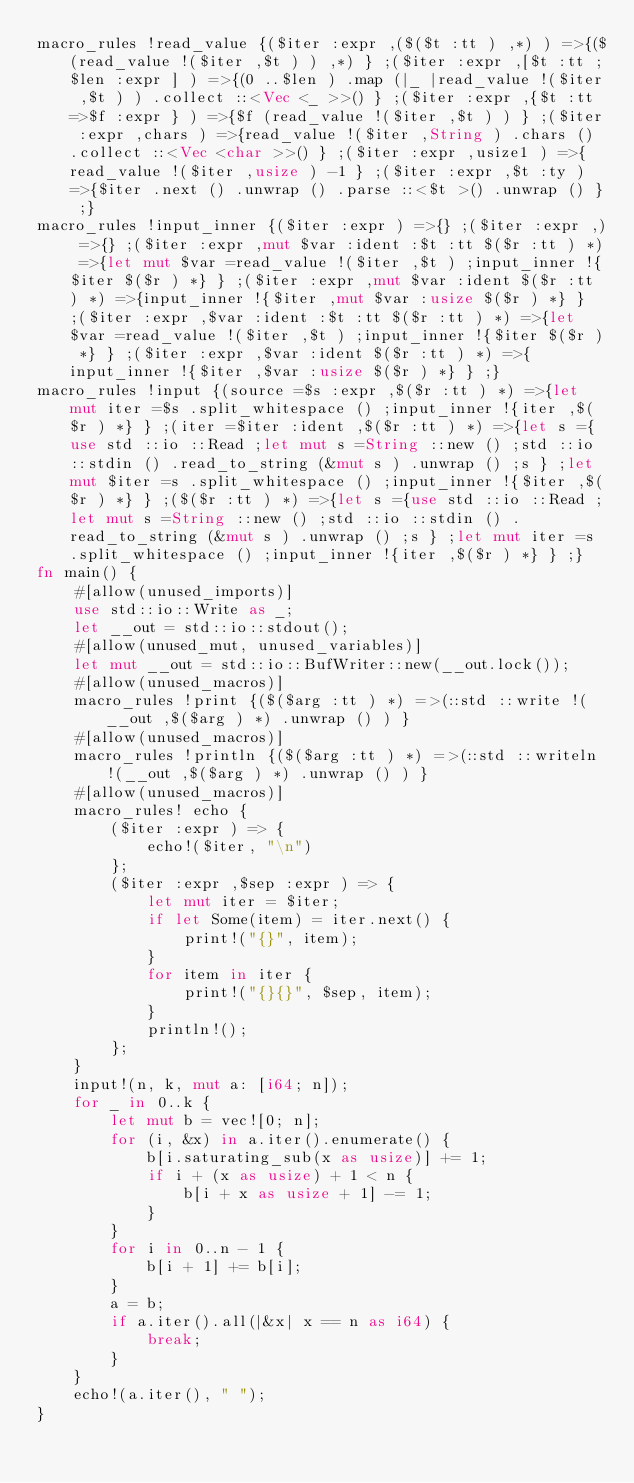<code> <loc_0><loc_0><loc_500><loc_500><_Rust_>macro_rules !read_value {($iter :expr ,($($t :tt ) ,*) ) =>{($(read_value !($iter ,$t ) ) ,*) } ;($iter :expr ,[$t :tt ;$len :expr ] ) =>{(0 ..$len ) .map (|_ |read_value !($iter ,$t ) ) .collect ::<Vec <_ >>() } ;($iter :expr ,{$t :tt =>$f :expr } ) =>{$f (read_value !($iter ,$t ) ) } ;($iter :expr ,chars ) =>{read_value !($iter ,String ) .chars () .collect ::<Vec <char >>() } ;($iter :expr ,usize1 ) =>{read_value !($iter ,usize ) -1 } ;($iter :expr ,$t :ty ) =>{$iter .next () .unwrap () .parse ::<$t >() .unwrap () } ;}
macro_rules !input_inner {($iter :expr ) =>{} ;($iter :expr ,) =>{} ;($iter :expr ,mut $var :ident :$t :tt $($r :tt ) *) =>{let mut $var =read_value !($iter ,$t ) ;input_inner !{$iter $($r ) *} } ;($iter :expr ,mut $var :ident $($r :tt ) *) =>{input_inner !{$iter ,mut $var :usize $($r ) *} } ;($iter :expr ,$var :ident :$t :tt $($r :tt ) *) =>{let $var =read_value !($iter ,$t ) ;input_inner !{$iter $($r ) *} } ;($iter :expr ,$var :ident $($r :tt ) *) =>{input_inner !{$iter ,$var :usize $($r ) *} } ;}
macro_rules !input {(source =$s :expr ,$($r :tt ) *) =>{let mut iter =$s .split_whitespace () ;input_inner !{iter ,$($r ) *} } ;(iter =$iter :ident ,$($r :tt ) *) =>{let s ={use std ::io ::Read ;let mut s =String ::new () ;std ::io ::stdin () .read_to_string (&mut s ) .unwrap () ;s } ;let mut $iter =s .split_whitespace () ;input_inner !{$iter ,$($r ) *} } ;($($r :tt ) *) =>{let s ={use std ::io ::Read ;let mut s =String ::new () ;std ::io ::stdin () .read_to_string (&mut s ) .unwrap () ;s } ;let mut iter =s .split_whitespace () ;input_inner !{iter ,$($r ) *} } ;}
fn main() {
    #[allow(unused_imports)]
    use std::io::Write as _;
    let __out = std::io::stdout();
    #[allow(unused_mut, unused_variables)]
    let mut __out = std::io::BufWriter::new(__out.lock());
    #[allow(unused_macros)]
    macro_rules !print {($($arg :tt ) *) =>(::std ::write !(__out ,$($arg ) *) .unwrap () ) }
    #[allow(unused_macros)]
    macro_rules !println {($($arg :tt ) *) =>(::std ::writeln !(__out ,$($arg ) *) .unwrap () ) }
    #[allow(unused_macros)]
    macro_rules! echo {
        ($iter :expr ) => {
            echo!($iter, "\n")
        };
        ($iter :expr ,$sep :expr ) => {
            let mut iter = $iter;
            if let Some(item) = iter.next() {
                print!("{}", item);
            }
            for item in iter {
                print!("{}{}", $sep, item);
            }
            println!();
        };
    }
    input!(n, k, mut a: [i64; n]);
    for _ in 0..k {
        let mut b = vec![0; n];
        for (i, &x) in a.iter().enumerate() {
            b[i.saturating_sub(x as usize)] += 1;
            if i + (x as usize) + 1 < n {
                b[i + x as usize + 1] -= 1;
            }
        }
        for i in 0..n - 1 {
            b[i + 1] += b[i];
        }
        a = b;
        if a.iter().all(|&x| x == n as i64) {
            break;
        }
    }
    echo!(a.iter(), " ");
}
</code> 